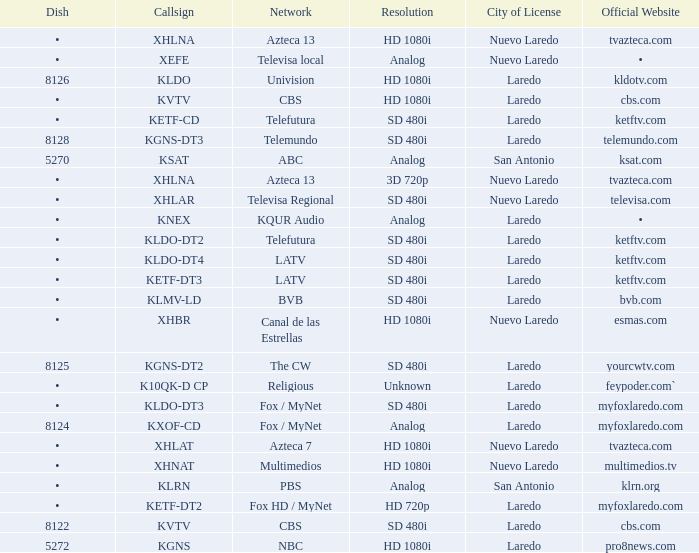Name the official website which has dish of • and callsign of kvtv Cbs.com. Give me the full table as a dictionary. {'header': ['Dish', 'Callsign', 'Network', 'Resolution', 'City of License', 'Official Website'], 'rows': [['•', 'XHLNA', 'Azteca 13', 'HD 1080i', 'Nuevo Laredo', 'tvazteca.com'], ['•', 'XEFE', 'Televisa local', 'Analog', 'Nuevo Laredo', '•'], ['8126', 'KLDO', 'Univision', 'HD 1080i', 'Laredo', 'kldotv.com'], ['•', 'KVTV', 'CBS', 'HD 1080i', 'Laredo', 'cbs.com'], ['•', 'KETF-CD', 'Telefutura', 'SD 480i', 'Laredo', 'ketftv.com'], ['8128', 'KGNS-DT3', 'Telemundo', 'SD 480i', 'Laredo', 'telemundo.com'], ['5270', 'KSAT', 'ABC', 'Analog', 'San Antonio', 'ksat.com'], ['•', 'XHLNA', 'Azteca 13', '3D 720p', 'Nuevo Laredo', 'tvazteca.com'], ['•', 'XHLAR', 'Televisa Regional', 'SD 480i', 'Nuevo Laredo', 'televisa.com'], ['•', 'KNEX', 'KQUR Audio', 'Analog', 'Laredo', '•'], ['•', 'KLDO-DT2', 'Telefutura', 'SD 480i', 'Laredo', 'ketftv.com'], ['•', 'KLDO-DT4', 'LATV', 'SD 480i', 'Laredo', 'ketftv.com'], ['•', 'KETF-DT3', 'LATV', 'SD 480i', 'Laredo', 'ketftv.com'], ['•', 'KLMV-LD', 'BVB', 'SD 480i', 'Laredo', 'bvb.com'], ['•', 'XHBR', 'Canal de las Estrellas', 'HD 1080i', 'Nuevo Laredo', 'esmas.com'], ['8125', 'KGNS-DT2', 'The CW', 'SD 480i', 'Laredo', 'yourcwtv.com'], ['•', 'K10QK-D CP', 'Religious', 'Unknown', 'Laredo', 'feypoder.com`'], ['•', 'KLDO-DT3', 'Fox / MyNet', 'SD 480i', 'Laredo', 'myfoxlaredo.com'], ['8124', 'KXOF-CD', 'Fox / MyNet', 'Analog', 'Laredo', 'myfoxlaredo.com'], ['•', 'XHLAT', 'Azteca 7', 'HD 1080i', 'Nuevo Laredo', 'tvazteca.com'], ['•', 'XHNAT', 'Multimedios', 'HD 1080i', 'Nuevo Laredo', 'multimedios.tv'], ['•', 'KLRN', 'PBS', 'Analog', 'San Antonio', 'klrn.org'], ['•', 'KETF-DT2', 'Fox HD / MyNet', 'HD 720p', 'Laredo', 'myfoxlaredo.com'], ['8122', 'KVTV', 'CBS', 'SD 480i', 'Laredo', 'cbs.com'], ['5272', 'KGNS', 'NBC', 'HD 1080i', 'Laredo', 'pro8news.com']]} 